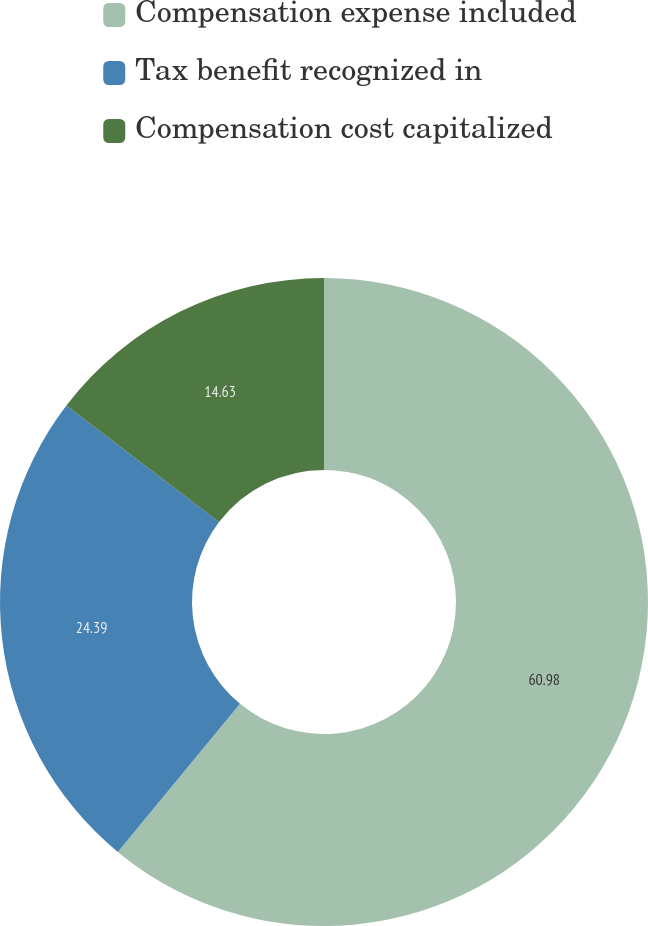Convert chart to OTSL. <chart><loc_0><loc_0><loc_500><loc_500><pie_chart><fcel>Compensation expense included<fcel>Tax benefit recognized in<fcel>Compensation cost capitalized<nl><fcel>60.98%<fcel>24.39%<fcel>14.63%<nl></chart> 